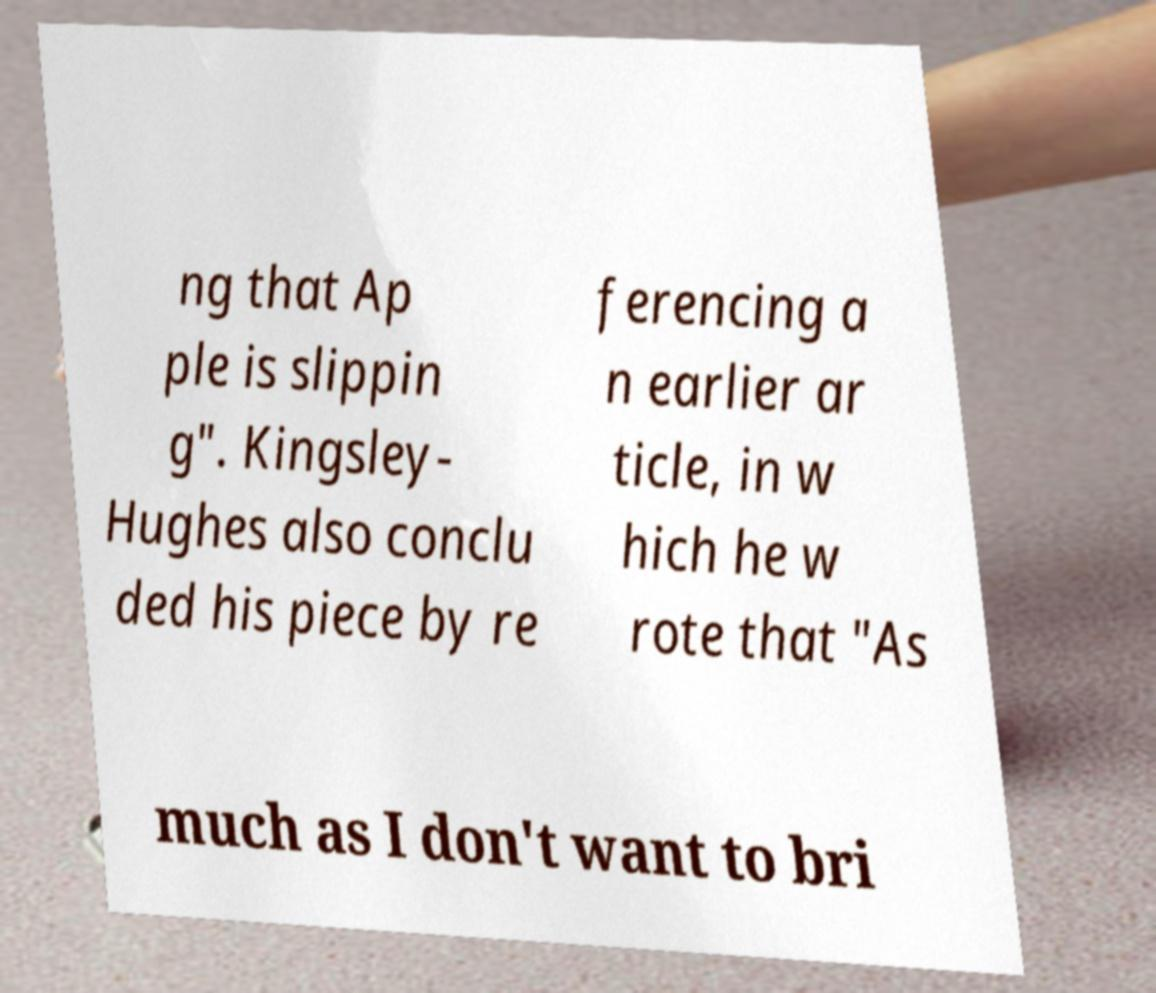Please identify and transcribe the text found in this image. ng that Ap ple is slippin g". Kingsley- Hughes also conclu ded his piece by re ferencing a n earlier ar ticle, in w hich he w rote that "As much as I don't want to bri 